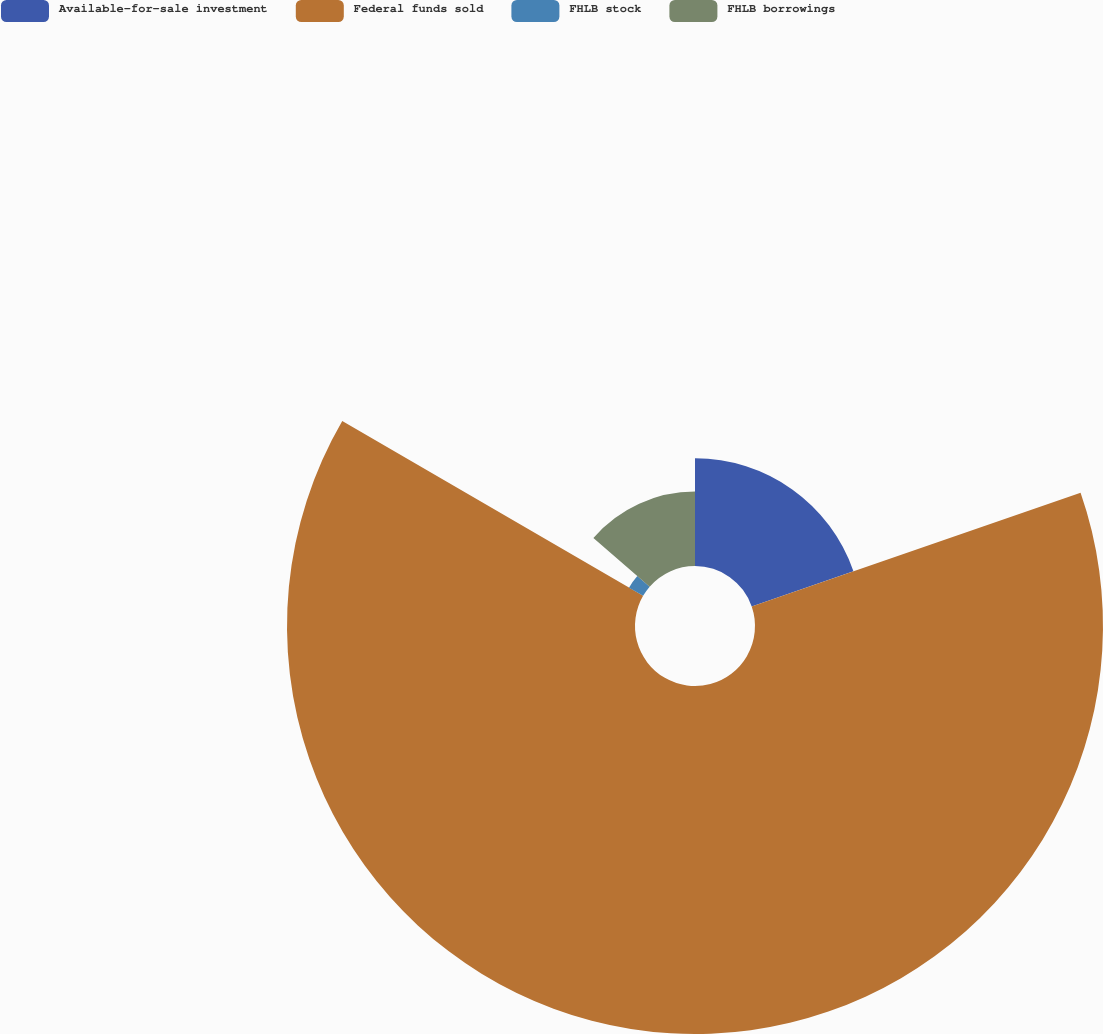<chart> <loc_0><loc_0><loc_500><loc_500><pie_chart><fcel>Available-for-sale investment<fcel>Federal funds sold<fcel>FHLB stock<fcel>FHLB borrowings<nl><fcel>19.7%<fcel>63.68%<fcel>2.99%<fcel>13.63%<nl></chart> 